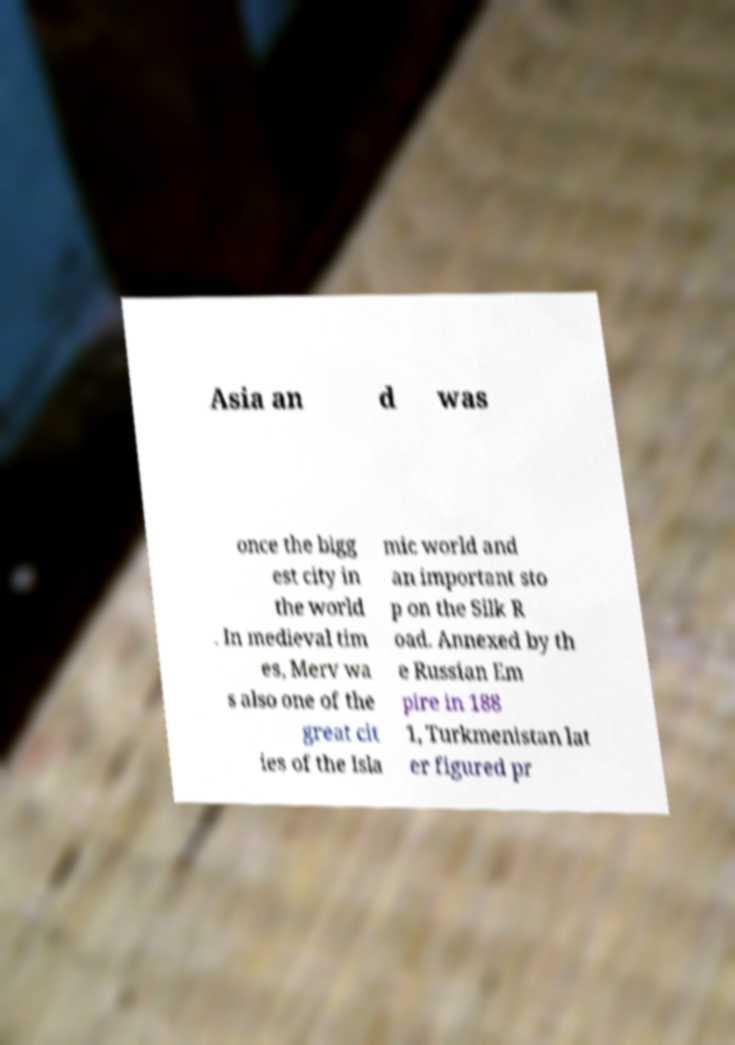Can you read and provide the text displayed in the image?This photo seems to have some interesting text. Can you extract and type it out for me? Asia an d was once the bigg est city in the world . In medieval tim es, Merv wa s also one of the great cit ies of the Isla mic world and an important sto p on the Silk R oad. Annexed by th e Russian Em pire in 188 1, Turkmenistan lat er figured pr 